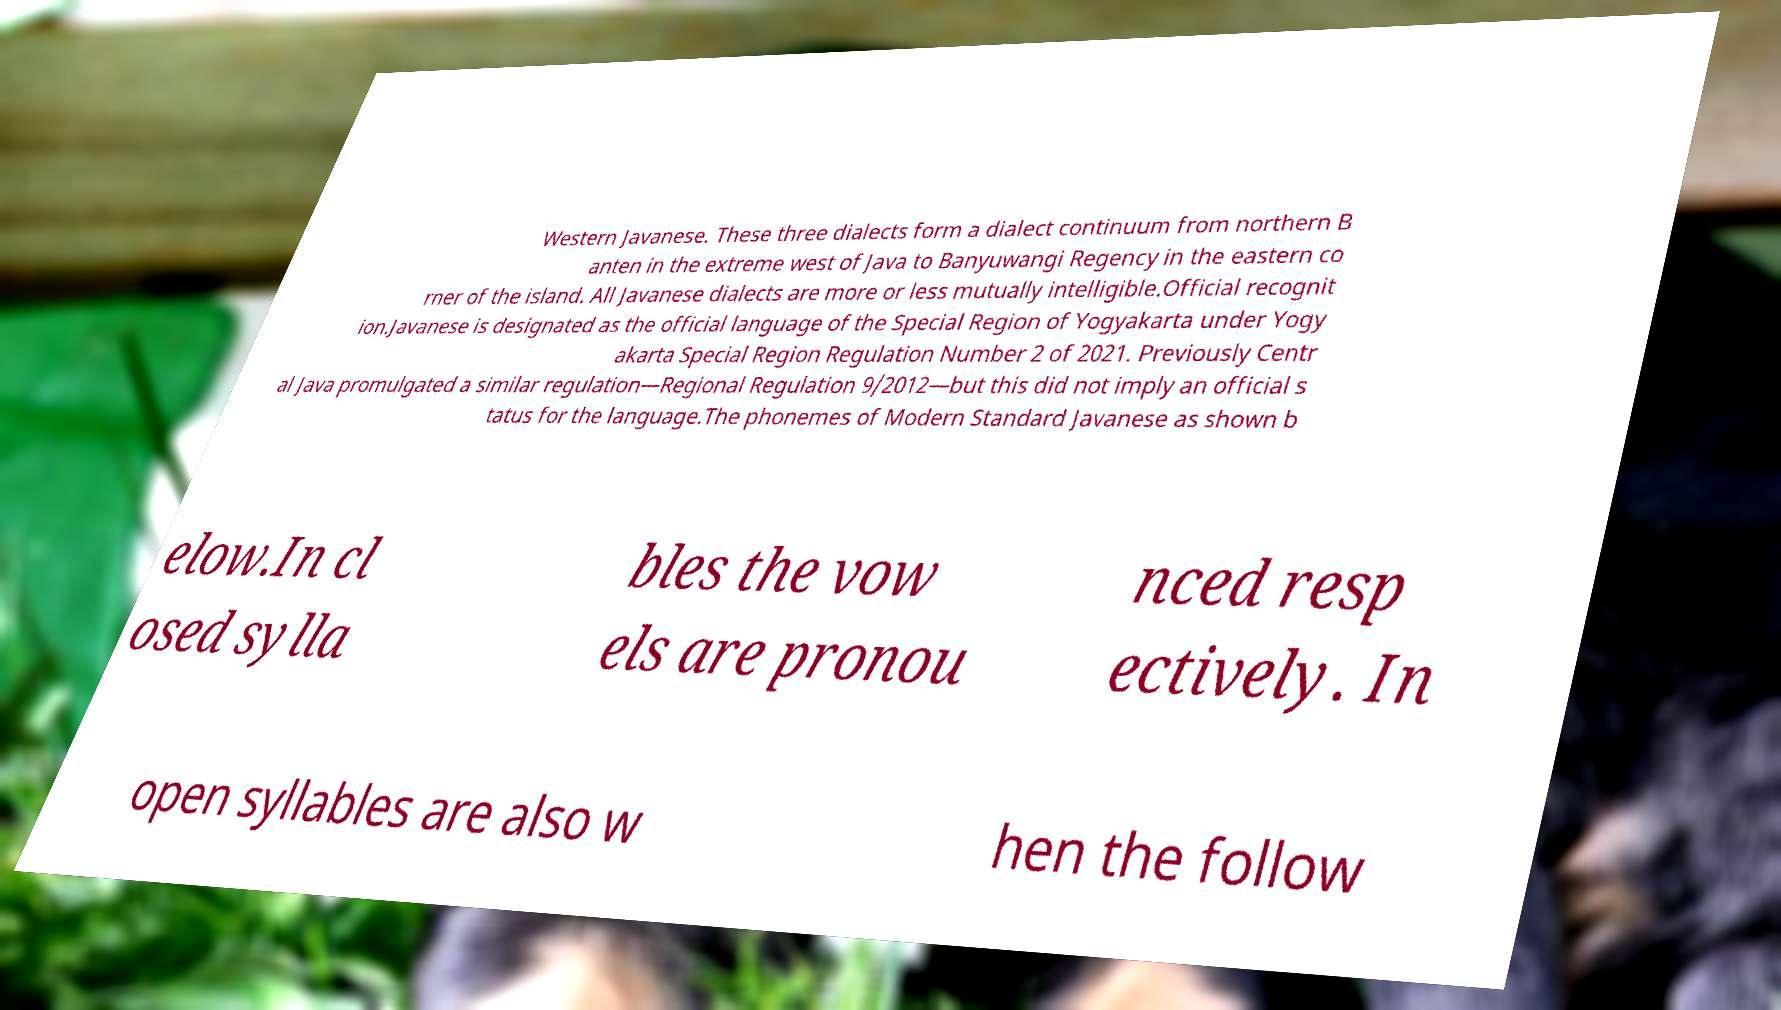Could you assist in decoding the text presented in this image and type it out clearly? Western Javanese. These three dialects form a dialect continuum from northern B anten in the extreme west of Java to Banyuwangi Regency in the eastern co rner of the island. All Javanese dialects are more or less mutually intelligible.Official recognit ion.Javanese is designated as the official language of the Special Region of Yogyakarta under Yogy akarta Special Region Regulation Number 2 of 2021. Previously Centr al Java promulgated a similar regulation—Regional Regulation 9/2012—but this did not imply an official s tatus for the language.The phonemes of Modern Standard Javanese as shown b elow.In cl osed sylla bles the vow els are pronou nced resp ectively. In open syllables are also w hen the follow 